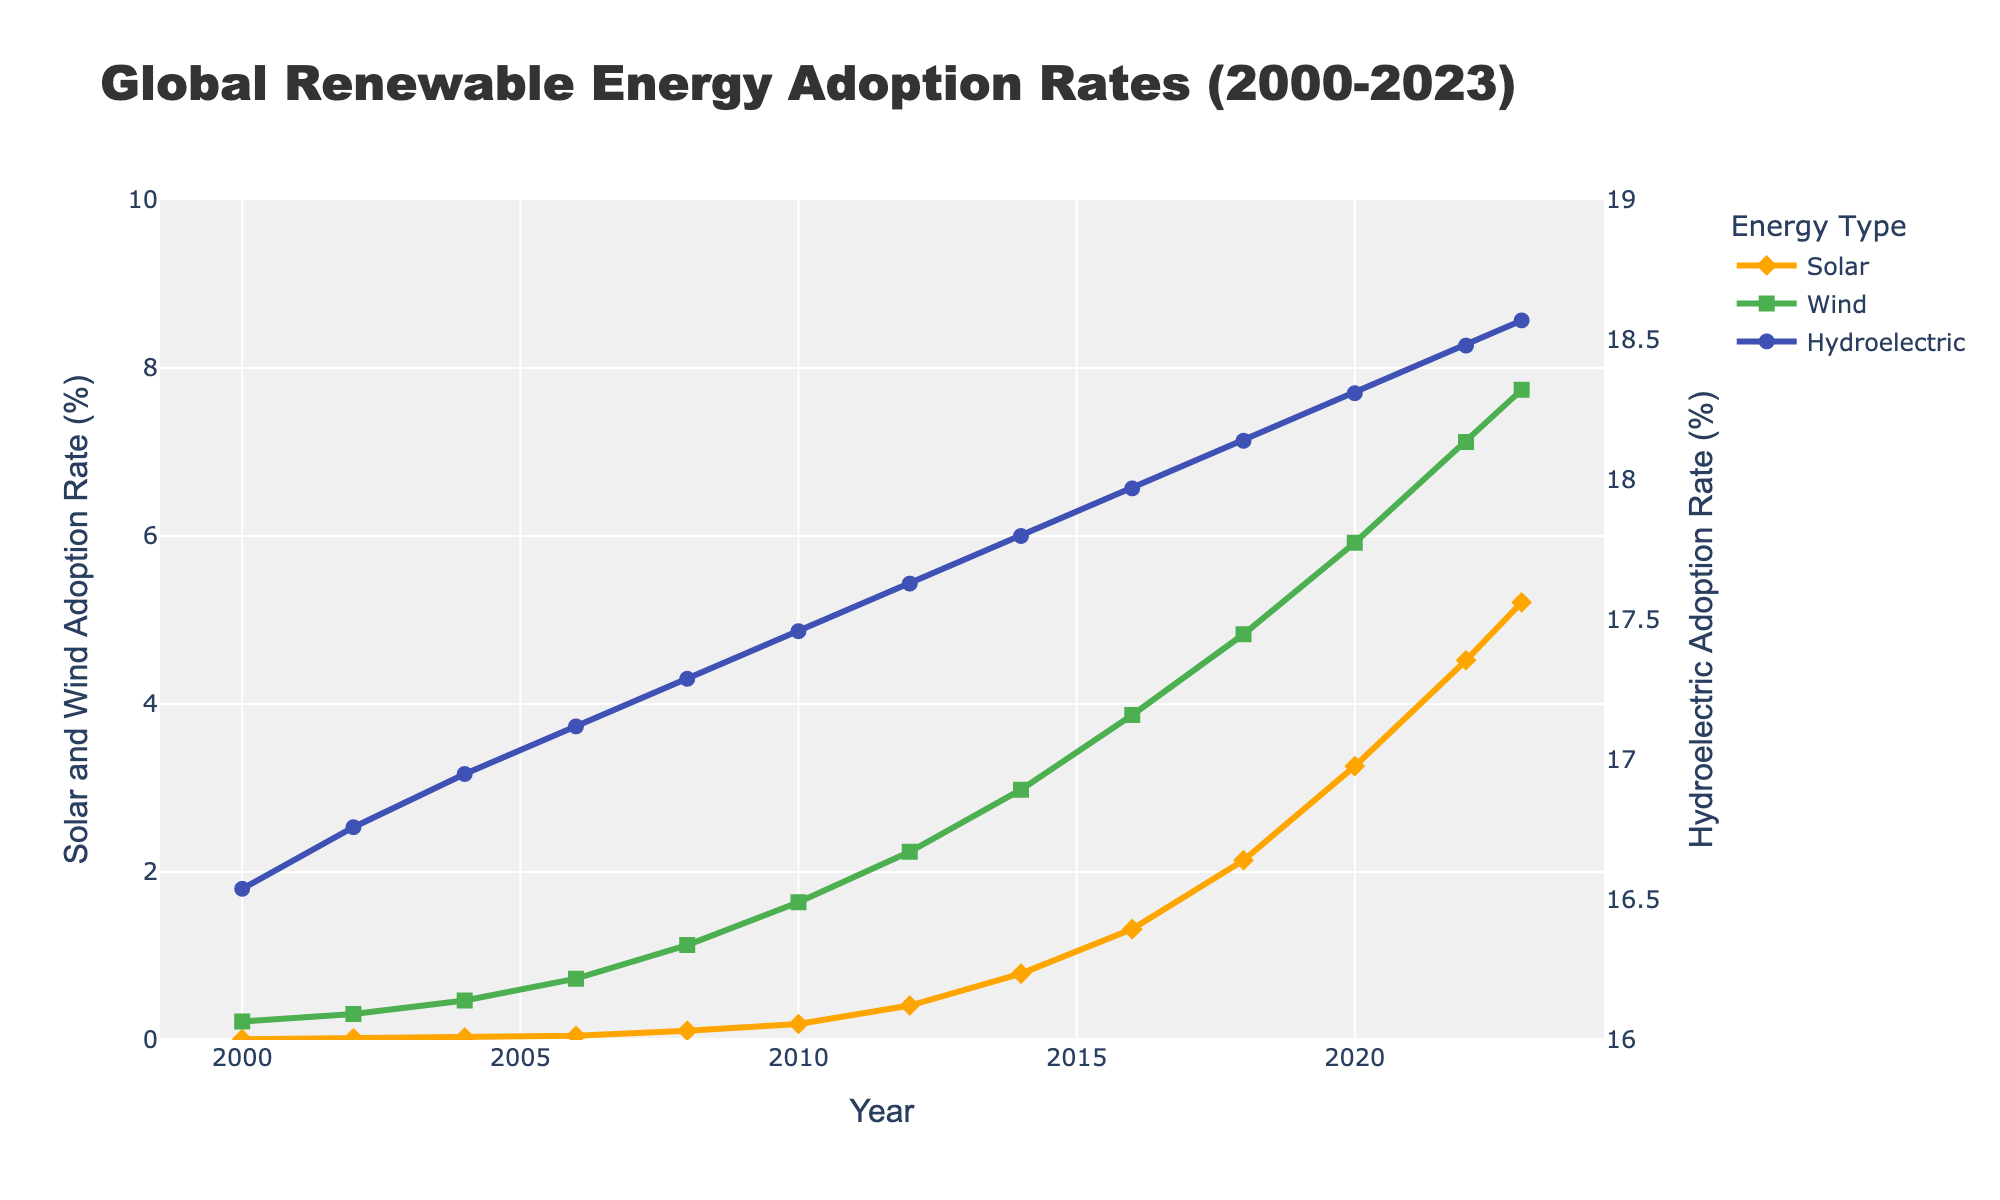What has the largest increase in adoption rates from 2000 to 2023, Solar or Wind? To determine the largest increase, compare the adoption rates of Solar and Wind in 2000 and 2023. Solar increased from 0.01% to 5.21% and Wind from 0.22% to 7.74%. The difference for Solar is 5.21 - 0.01 = 5.20 and for Wind is 7.74 - 0.22 = 7.52.
Answer: Wind What is the overall trend of hydroelectric adoption over the years? Observing the trend line for hydroelectric adoption from 2000 to 2023, there is a gradual increase from 16.54% in 2000 to 18.57% in 2023.
Answer: Gradually increasing Which year saw the fastest increase in Solar adoption rates compared to the previous years? To find the fastest increase, calculate the year-to-year differences for Solar and identify the largest increment. The largest increase for Solar is from 2012 (0.41%) to 2014 (0.79%), which is 0.38%.
Answer: 2012 to 2014 In what year did Wind adoption surpass 1% for the first time? Track the Wind adoption figures in each year to identify when it first exceeds 1%. In 2008, it is 1.13%.
Answer: 2008 Compare the rate of adoption of Solar and Wind in 2010. Which one had higher adoption? Check the adoption rates in 2010 for both Solar and Wind. Solar is at 0.19% and Wind is at 1.64%. Clearly, Wind had higher adoption.
Answer: Wind By how much did the adoption rate of Hydroelectric energy change from 2012 to 2023? Subtract the Hydroelectric rate in 2012 (17.63%) from the rate in 2023 (18.57%). The change is 18.57 - 17.63 = 0.94.
Answer: 0.94% Which renewable energy type had the smallest increase in adoption rate from 2000 to 2023? Compare the increases for all three types from 2000 to 2023. Solar increased by 5.20%, Wind by 7.52%, and Hydroelectric by 2.03%. The smallest increase is for Hydroelectric.
Answer: Hydroelectric What colors are used to represent Solar, Wind, and Hydroelectric in the figure? Identify colors from the plot's legend or lines. Solar is orange, Wind is green, and Hydroelectric is blue.
Answer: Orange for Solar, Green for Wind, Blue for Hydroelectric What are the adoption rates of Solar and Wind in 2023? Check the plot for the rates in 2023. Solar is at 5.21% and Wind is at 7.74%.
Answer: Solar: 5.21%, Wind: 7.74% What was the adoption rate of Hydroelectric energy in 2010? Locate the value for Hydroelectric in 2010 on the plot. It is 17.46%.
Answer: 17.46% 